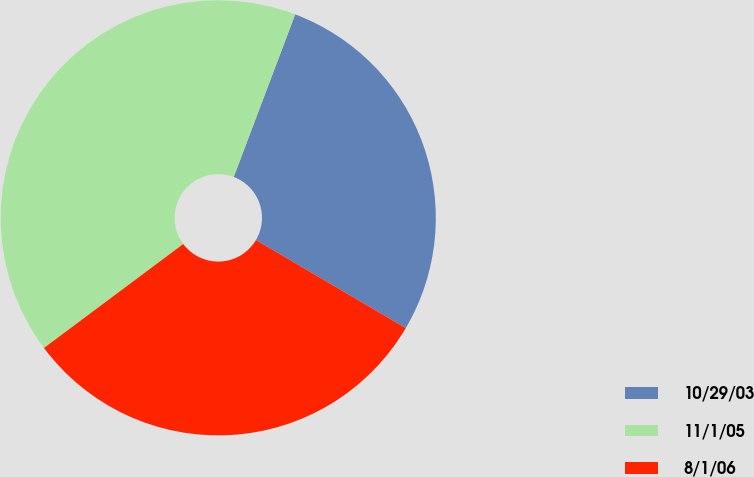Convert chart to OTSL. <chart><loc_0><loc_0><loc_500><loc_500><pie_chart><fcel>10/29/03<fcel>11/1/05<fcel>8/1/06<nl><fcel>27.71%<fcel>40.96%<fcel>31.33%<nl></chart> 